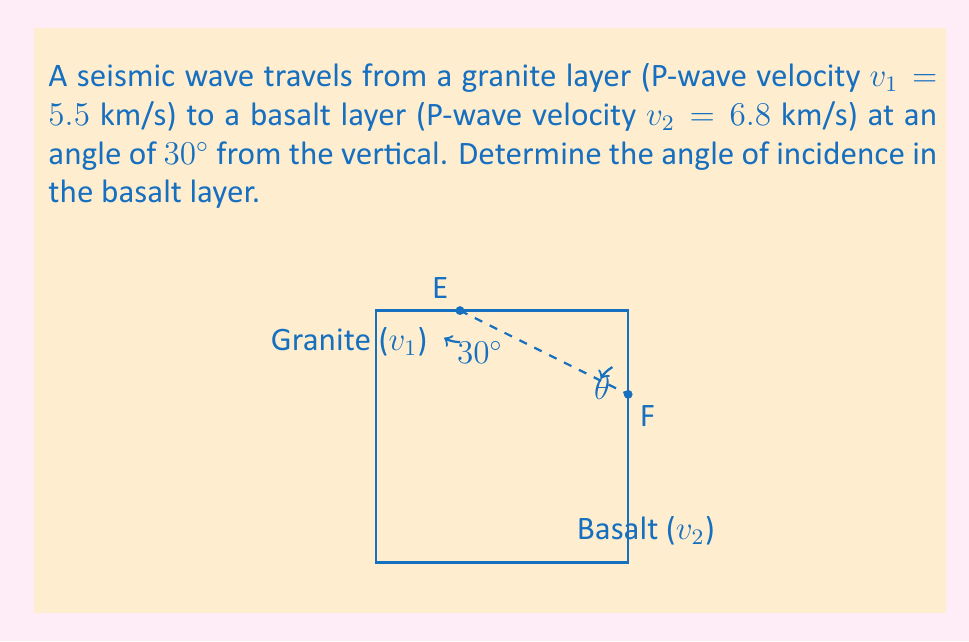Show me your answer to this math problem. To solve this problem, we'll use Snell's law, which describes how waves refract when passing between media with different velocities. The formula is:

$$\frac{\sin \theta_1}{v_1} = \frac{\sin \theta_2}{v_2}$$

Where:
$\theta_1$ is the angle of incidence in the first medium (granite)
$\theta_2$ is the angle of refraction in the second medium (basalt)
$v_1$ is the wave velocity in the first medium
$v_2$ is the wave velocity in the second medium

We're given:
$\theta_1 = 30^\circ$ (complement of the angle from vertical)
$v_1 = 5.5$ km/s
$v_2 = 6.8$ km/s

Let's solve for $\theta_2$:

1) Apply Snell's law:
   $$\frac{\sin 30^\circ}{5.5} = \frac{\sin \theta_2}{6.8}$$

2) Cross multiply:
   $$6.8 \sin 30^\circ = 5.5 \sin \theta_2$$

3) Solve for $\sin \theta_2$:
   $$\sin \theta_2 = \frac{6.8 \sin 30^\circ}{5.5}$$

4) Calculate:
   $$\sin \theta_2 = \frac{6.8 \cdot 0.5}{5.5} \approx 0.6182$$

5) Take the inverse sine (arcsin) of both sides:
   $$\theta_2 = \arcsin(0.6182) \approx 38.15^\circ$$

Therefore, the angle of incidence in the basalt layer is approximately $38.15^\circ$.
Answer: $38.15^\circ$ 